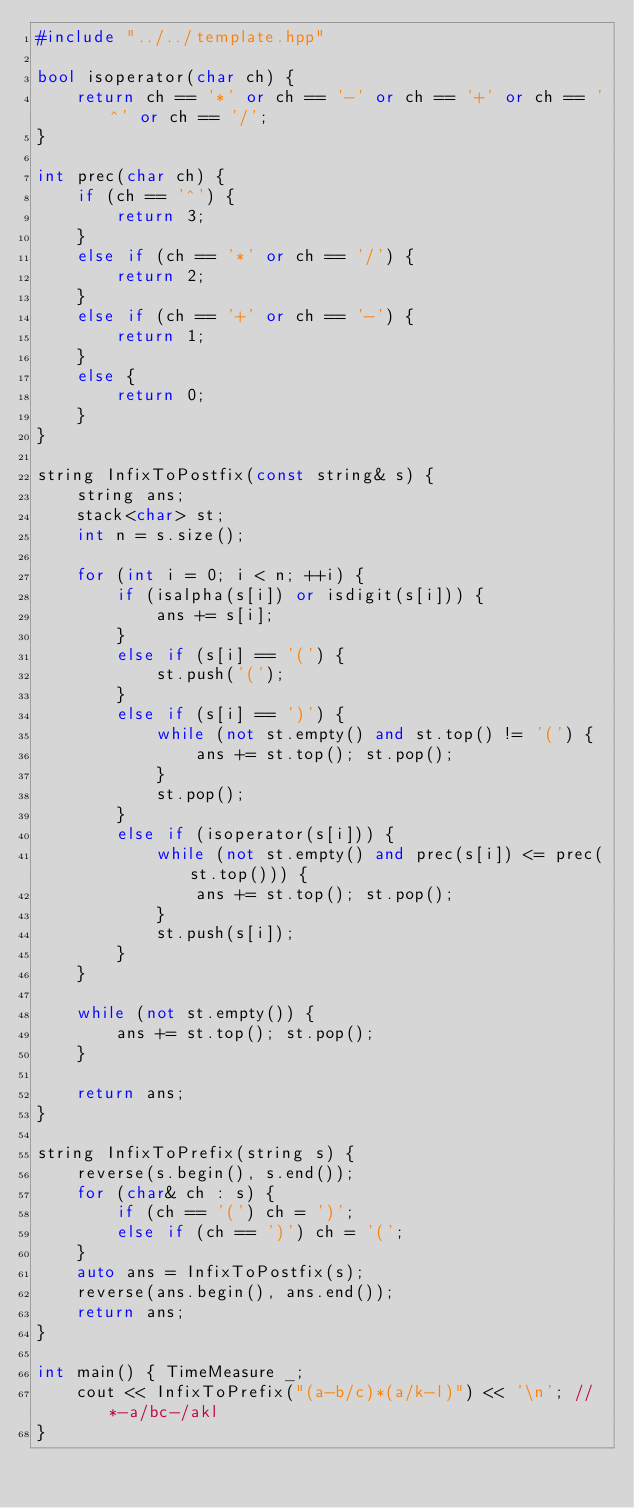<code> <loc_0><loc_0><loc_500><loc_500><_C++_>#include "../../template.hpp"

bool isoperator(char ch) {
    return ch == '*' or ch == '-' or ch == '+' or ch == '^' or ch == '/';
}

int prec(char ch) {
    if (ch == '^') {
        return 3;
    }
    else if (ch == '*' or ch == '/') {
        return 2;
    }
    else if (ch == '+' or ch == '-') {
        return 1;
    }
    else {
        return 0;
    }
}

string InfixToPostfix(const string& s) {
    string ans;
    stack<char> st;
    int n = s.size();

    for (int i = 0; i < n; ++i) {
        if (isalpha(s[i]) or isdigit(s[i])) {
            ans += s[i];
        }
        else if (s[i] == '(') {
            st.push('(');
        }
        else if (s[i] == ')') {
            while (not st.empty() and st.top() != '(') {
                ans += st.top(); st.pop();
            }
            st.pop();
        }
        else if (isoperator(s[i])) {
            while (not st.empty() and prec(s[i]) <= prec(st.top())) {
                ans += st.top(); st.pop();
            }
            st.push(s[i]);
        }
    }

    while (not st.empty()) {
        ans += st.top(); st.pop();
    }

    return ans;
}

string InfixToPrefix(string s) {
    reverse(s.begin(), s.end());
    for (char& ch : s) {
        if (ch == '(') ch = ')';
        else if (ch == ')') ch = '(';
    }
    auto ans = InfixToPostfix(s);
    reverse(ans.begin(), ans.end());
    return ans;
}

int main() { TimeMeasure _;
    cout << InfixToPrefix("(a-b/c)*(a/k-l)") << '\n'; //*-a/bc-/akl
}
</code> 